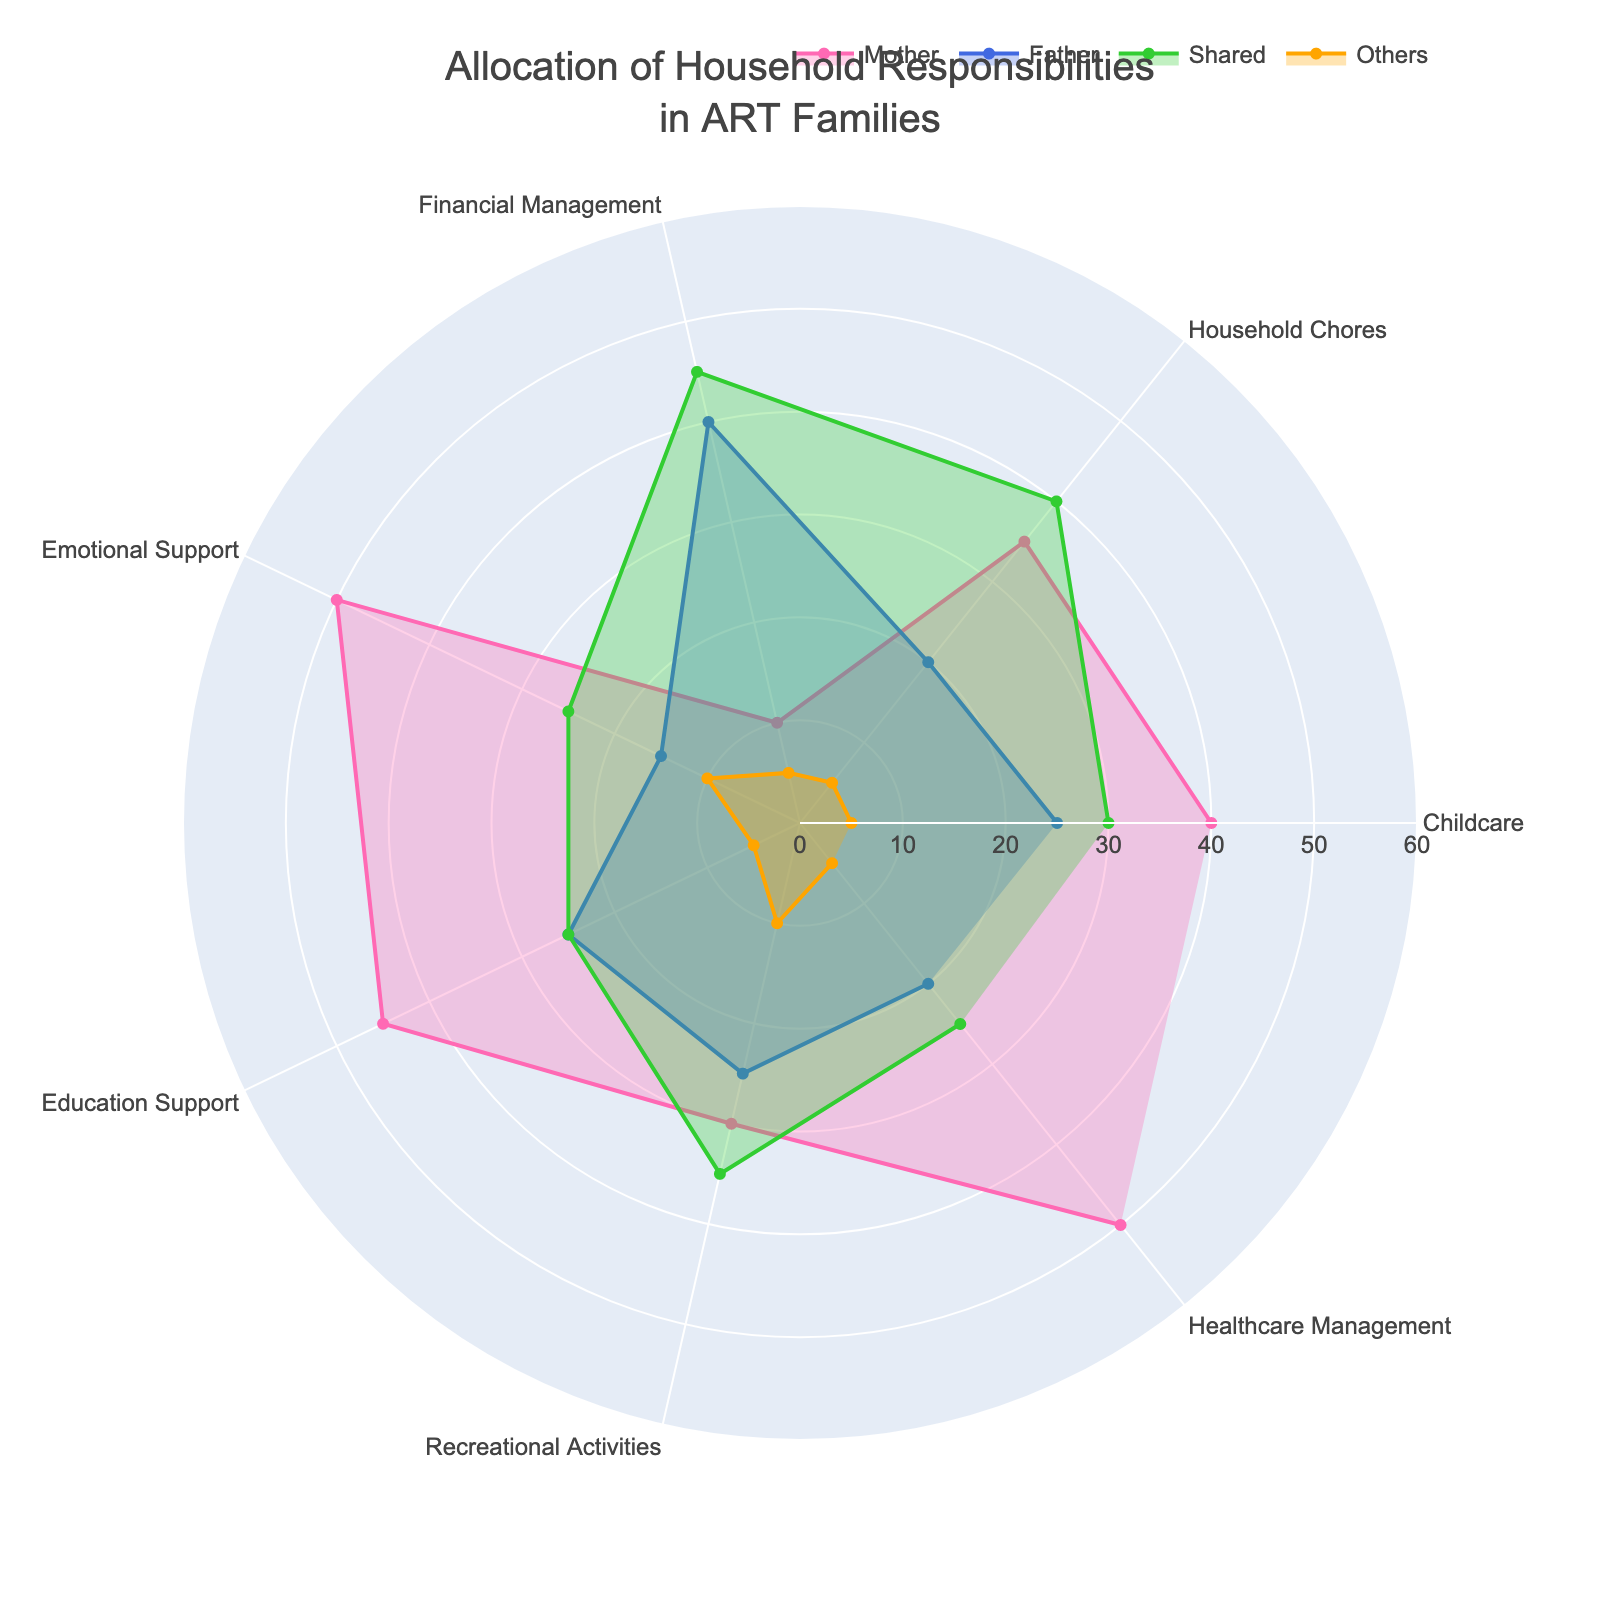What's the most common allocation for Financial Management? The figure shows that the responsibilities of Financial Management are broken down into Mother, Father, Shared, and Others. The highest value must be identified. According to the data, the highest allocation is Shared at 45%.
Answer: Shared Which responsibility category has the highest allocation for Mothers? Locate the highest value in the Mother's section across all categories. The highest value for Mother is 50%, which appears in Emotional Support and Healthcare Management.
Answer: Emotional Support and Healthcare Management What is the average percentage allocation for Fathers across all categories? Sum the allocation values for Fathers across all categories and divide by the number of categories. (25 + 20 + 40 + 15 + 25 + 25 + 20)/7 = 170/7 ≈ 24.29%
Answer: Approximately 24.29% Do Mothers or Fathers spend more time on Childcare? Compare the values in the Childcare category for Mothers and Fathers. The allocation for Mother is 40% and for Father is 25%.
Answer: Mother For which category is the responsibility most shared between Mother and Father? Determine the category where the sum of Mother and Father's allocation is highest combined. Shared allocation is considered here as well to assess. In this scenario, Financial Management and Recreational Activities have higher shared values compared to the direct allocation tendency of Mother and Father. But focused on only Mother and Father, the answer is Emotional Support.
Answer: Emotional Support What's the combined percentage of Mothers' time spent on Household Chores and Healthcare Management? Add the percentage allocations of Mother for Household Chores and Healthcare Management. 35% (Household Chores) + 50% (Healthcare Management) = 85%
Answer: 85% Which category shows the most balanced distribution between Mother, Father, and Shared? Identify the category where the values of Mother, Father, and Shared are closest to each other. Recreational Activities shows values as 30% (Mother), 25% (Father), and 35% (Shared), hence quite balanced.
Answer: Recreational Activities How much more does Mother contribute to Education Support compared to Father? Compute the difference between Mother's and Father's contributions in Education Support. 45% (Mother) - 25% (Father) = 20%
Answer: 20% In which category does the 'Others' group have the highest responsibility allocation? Identify the highest value in the 'Others' section of the chart. The highest value in "Others" is Emotional Support at 10%.
Answer: Emotional Support 